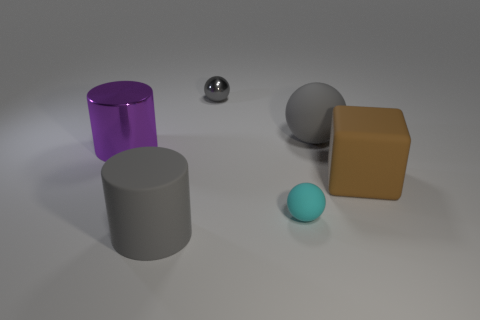There is a gray matte thing in front of the cyan rubber object; what size is it?
Offer a very short reply. Large. There is a cylinder that is the same material as the big gray sphere; what size is it?
Offer a very short reply. Large. How many small metallic spheres are the same color as the big rubber cylinder?
Provide a succinct answer. 1. Are any tiny metallic blocks visible?
Provide a short and direct response. No. Do the purple thing and the big gray object that is in front of the purple metal cylinder have the same shape?
Your answer should be very brief. Yes. There is a shiny thing right of the large matte thing in front of the cube that is behind the cyan sphere; what is its color?
Provide a succinct answer. Gray. Are there any gray spheres right of the purple cylinder?
Give a very brief answer. Yes. There is a matte sphere that is the same color as the tiny metallic object; what size is it?
Ensure brevity in your answer.  Large. Are there any brown blocks that have the same material as the cyan thing?
Offer a very short reply. Yes. What color is the big rubber ball?
Your answer should be very brief. Gray. 